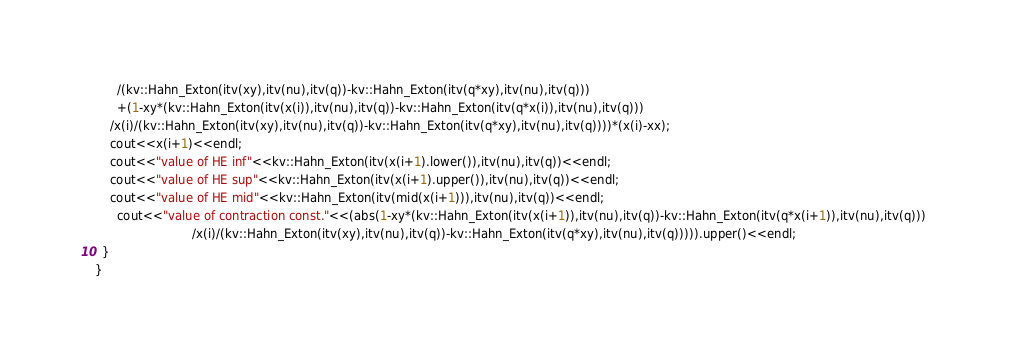Convert code to text. <code><loc_0><loc_0><loc_500><loc_500><_C++_>      /(kv::Hahn_Exton(itv(xy),itv(nu),itv(q))-kv::Hahn_Exton(itv(q*xy),itv(nu),itv(q)))
      +(1-xy*(kv::Hahn_Exton(itv(x(i)),itv(nu),itv(q))-kv::Hahn_Exton(itv(q*x(i)),itv(nu),itv(q))) 
	/x(i)/(kv::Hahn_Exton(itv(xy),itv(nu),itv(q))-kv::Hahn_Exton(itv(q*xy),itv(nu),itv(q))))*(x(i)-xx);
    cout<<x(i+1)<<endl;
    cout<<"value of HE inf"<<kv::Hahn_Exton(itv(x(i+1).lower()),itv(nu),itv(q))<<endl;
    cout<<"value of HE sup"<<kv::Hahn_Exton(itv(x(i+1).upper()),itv(nu),itv(q))<<endl;
    cout<<"value of HE mid"<<kv::Hahn_Exton(itv(mid(x(i+1))),itv(nu),itv(q))<<endl;
      cout<<"value of contraction const."<<(abs(1-xy*(kv::Hahn_Exton(itv(x(i+1)),itv(nu),itv(q))-kv::Hahn_Exton(itv(q*x(i+1)),itv(nu),itv(q))) 
					      /x(i)/(kv::Hahn_Exton(itv(xy),itv(nu),itv(q))-kv::Hahn_Exton(itv(q*xy),itv(nu),itv(q))))).upper()<<endl;
  }
}
</code> 